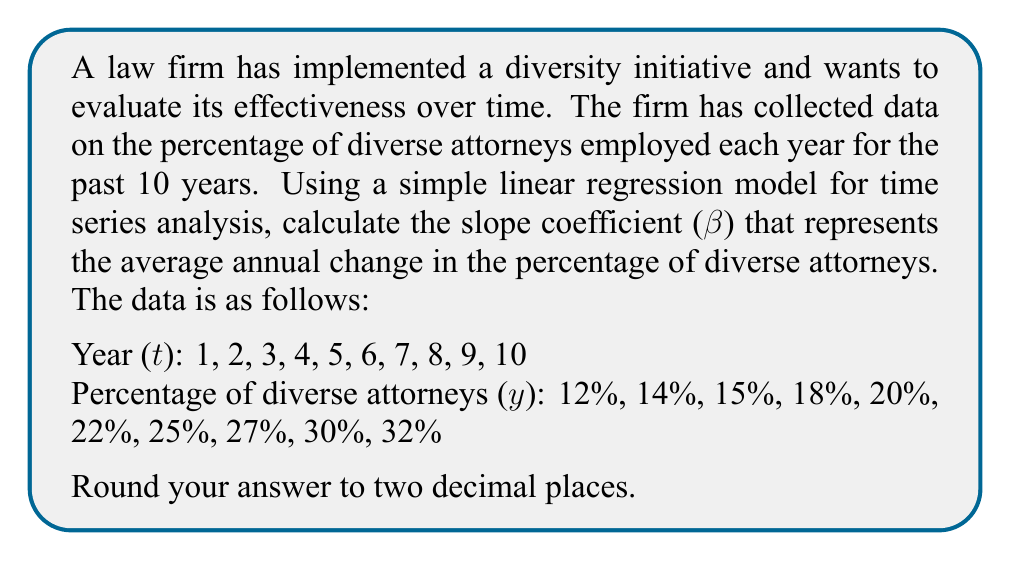Help me with this question. To calculate the slope coefficient (β) using simple linear regression for time series data, we can use the following formula:

$$ \beta = \frac{n\sum_{i=1}^n t_i y_i - \sum_{i=1}^n t_i \sum_{i=1}^n y_i}{n\sum_{i=1}^n t_i^2 - (\sum_{i=1}^n t_i)^2} $$

Where:
n = number of observations
t = time variable (year)
y = percentage of diverse attorneys

Step 1: Calculate the required sums:
$\sum_{i=1}^n t_i = 1 + 2 + 3 + 4 + 5 + 6 + 7 + 8 + 9 + 10 = 55$
$\sum_{i=1}^n y_i = 12 + 14 + 15 + 18 + 20 + 22 + 25 + 27 + 30 + 32 = 215$
$\sum_{i=1}^n t_i y_i = (1×12) + (2×14) + (3×15) + (4×18) + (5×20) + (6×22) + (7×25) + (8×27) + (9×30) + (10×32) = 1,435$
$\sum_{i=1}^n t_i^2 = 1^2 + 2^2 + 3^2 + 4^2 + 5^2 + 6^2 + 7^2 + 8^2 + 9^2 + 10^2 = 385$

Step 2: Apply the formula:

$$ \beta = \frac{10(1,435) - (55)(215)}{10(385) - (55)^2} $$

$$ \beta = \frac{14,350 - 11,825}{3,850 - 3,025} $$

$$ \beta = \frac{2,525}{825} $$

$$ \beta = 3.0606... $$

Step 3: Round to two decimal places:

$$ \beta ≈ 3.06 $$

This slope coefficient represents the average annual increase in the percentage of diverse attorneys at the firm over the 10-year period.
Answer: 3.06 